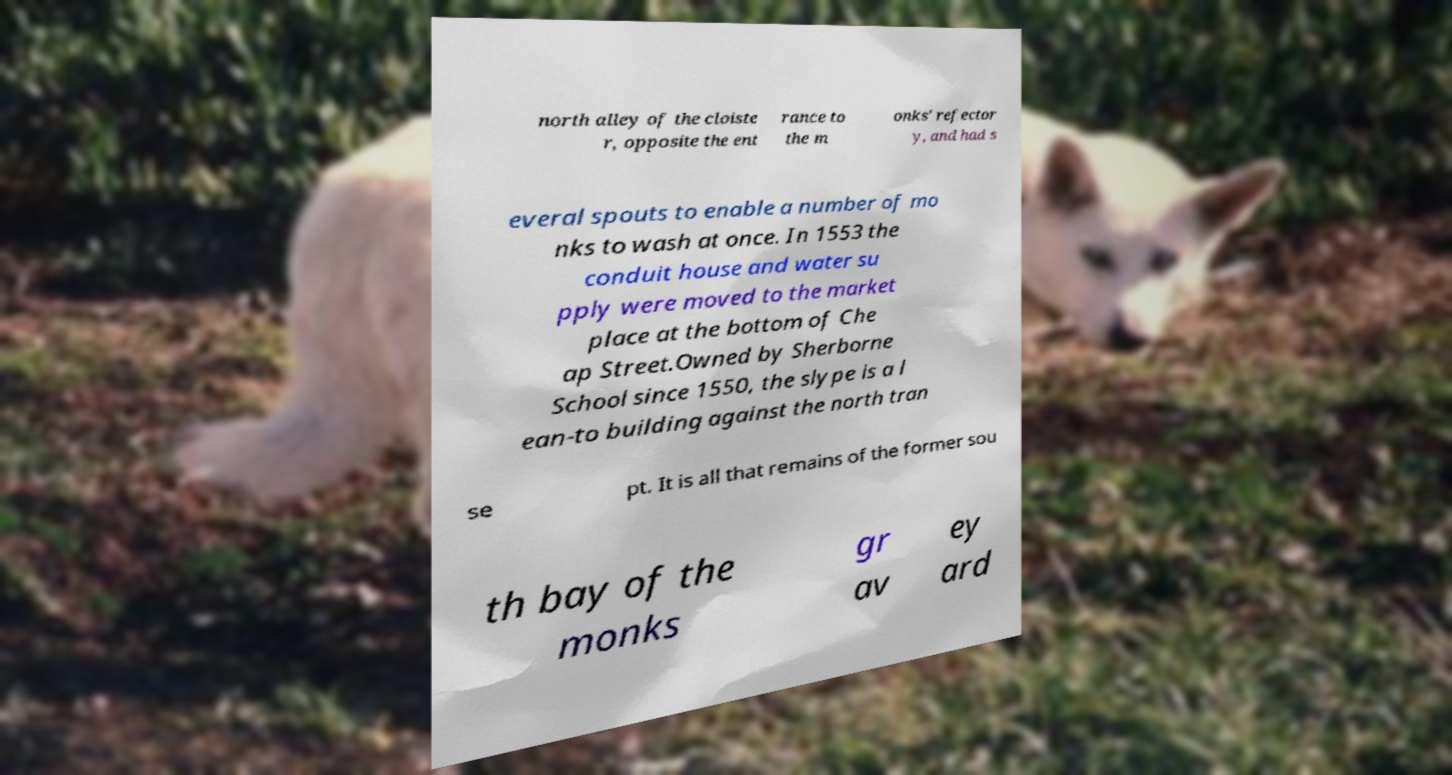Can you read and provide the text displayed in the image?This photo seems to have some interesting text. Can you extract and type it out for me? north alley of the cloiste r, opposite the ent rance to the m onks' refector y, and had s everal spouts to enable a number of mo nks to wash at once. In 1553 the conduit house and water su pply were moved to the market place at the bottom of Che ap Street.Owned by Sherborne School since 1550, the slype is a l ean-to building against the north tran se pt. It is all that remains of the former sou th bay of the monks gr av ey ard 